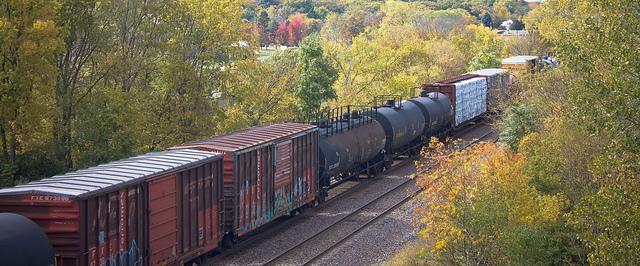How many train tracks do you see?
Give a very brief answer. 2. How many boats can you see in the water?
Give a very brief answer. 0. 